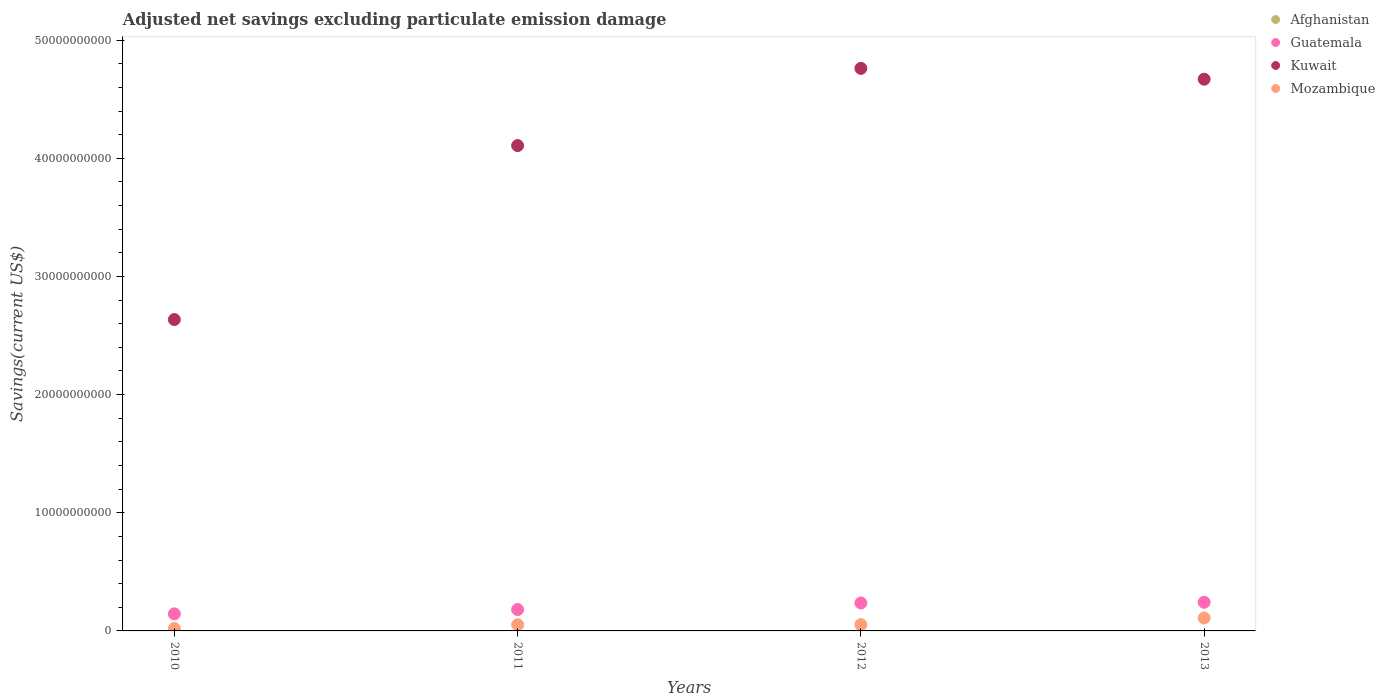What is the adjusted net savings in Mozambique in 2013?
Give a very brief answer. 1.09e+09. Across all years, what is the maximum adjusted net savings in Mozambique?
Your answer should be compact. 1.09e+09. Across all years, what is the minimum adjusted net savings in Mozambique?
Ensure brevity in your answer.  2.04e+08. What is the total adjusted net savings in Afghanistan in the graph?
Give a very brief answer. 0. What is the difference between the adjusted net savings in Guatemala in 2012 and that in 2013?
Make the answer very short. -5.85e+07. What is the difference between the adjusted net savings in Guatemala in 2012 and the adjusted net savings in Mozambique in 2010?
Your answer should be very brief. 2.16e+09. What is the average adjusted net savings in Mozambique per year?
Your answer should be very brief. 5.89e+08. In the year 2011, what is the difference between the adjusted net savings in Mozambique and adjusted net savings in Guatemala?
Provide a short and direct response. -1.28e+09. In how many years, is the adjusted net savings in Kuwait greater than 44000000000 US$?
Provide a short and direct response. 2. What is the ratio of the adjusted net savings in Kuwait in 2010 to that in 2012?
Provide a short and direct response. 0.55. Is the adjusted net savings in Mozambique in 2010 less than that in 2013?
Provide a short and direct response. Yes. Is the difference between the adjusted net savings in Mozambique in 2011 and 2013 greater than the difference between the adjusted net savings in Guatemala in 2011 and 2013?
Make the answer very short. Yes. What is the difference between the highest and the second highest adjusted net savings in Guatemala?
Ensure brevity in your answer.  5.85e+07. What is the difference between the highest and the lowest adjusted net savings in Kuwait?
Keep it short and to the point. 2.13e+1. In how many years, is the adjusted net savings in Mozambique greater than the average adjusted net savings in Mozambique taken over all years?
Keep it short and to the point. 1. Is the sum of the adjusted net savings in Kuwait in 2010 and 2011 greater than the maximum adjusted net savings in Guatemala across all years?
Give a very brief answer. Yes. Is it the case that in every year, the sum of the adjusted net savings in Kuwait and adjusted net savings in Afghanistan  is greater than the adjusted net savings in Guatemala?
Keep it short and to the point. Yes. Does the adjusted net savings in Kuwait monotonically increase over the years?
Keep it short and to the point. No. How many dotlines are there?
Give a very brief answer. 3. What is the difference between two consecutive major ticks on the Y-axis?
Provide a short and direct response. 1.00e+1. Does the graph contain grids?
Your answer should be very brief. No. How many legend labels are there?
Your answer should be very brief. 4. How are the legend labels stacked?
Keep it short and to the point. Vertical. What is the title of the graph?
Give a very brief answer. Adjusted net savings excluding particulate emission damage. Does "Kosovo" appear as one of the legend labels in the graph?
Offer a very short reply. No. What is the label or title of the X-axis?
Your answer should be very brief. Years. What is the label or title of the Y-axis?
Provide a short and direct response. Savings(current US$). What is the Savings(current US$) of Guatemala in 2010?
Offer a very short reply. 1.44e+09. What is the Savings(current US$) in Kuwait in 2010?
Provide a short and direct response. 2.64e+1. What is the Savings(current US$) in Mozambique in 2010?
Keep it short and to the point. 2.04e+08. What is the Savings(current US$) in Afghanistan in 2011?
Your answer should be compact. 0. What is the Savings(current US$) in Guatemala in 2011?
Provide a short and direct response. 1.81e+09. What is the Savings(current US$) of Kuwait in 2011?
Give a very brief answer. 4.11e+1. What is the Savings(current US$) in Mozambique in 2011?
Your answer should be very brief. 5.23e+08. What is the Savings(current US$) of Afghanistan in 2012?
Keep it short and to the point. 0. What is the Savings(current US$) in Guatemala in 2012?
Ensure brevity in your answer.  2.36e+09. What is the Savings(current US$) of Kuwait in 2012?
Your answer should be very brief. 4.76e+1. What is the Savings(current US$) in Mozambique in 2012?
Provide a short and direct response. 5.34e+08. What is the Savings(current US$) of Guatemala in 2013?
Offer a terse response. 2.42e+09. What is the Savings(current US$) in Kuwait in 2013?
Make the answer very short. 4.67e+1. What is the Savings(current US$) of Mozambique in 2013?
Provide a succinct answer. 1.09e+09. Across all years, what is the maximum Savings(current US$) of Guatemala?
Your response must be concise. 2.42e+09. Across all years, what is the maximum Savings(current US$) in Kuwait?
Ensure brevity in your answer.  4.76e+1. Across all years, what is the maximum Savings(current US$) in Mozambique?
Offer a terse response. 1.09e+09. Across all years, what is the minimum Savings(current US$) of Guatemala?
Offer a very short reply. 1.44e+09. Across all years, what is the minimum Savings(current US$) in Kuwait?
Make the answer very short. 2.64e+1. Across all years, what is the minimum Savings(current US$) of Mozambique?
Give a very brief answer. 2.04e+08. What is the total Savings(current US$) in Afghanistan in the graph?
Your answer should be very brief. 0. What is the total Savings(current US$) in Guatemala in the graph?
Your answer should be compact. 8.04e+09. What is the total Savings(current US$) of Kuwait in the graph?
Make the answer very short. 1.62e+11. What is the total Savings(current US$) in Mozambique in the graph?
Offer a terse response. 2.36e+09. What is the difference between the Savings(current US$) of Guatemala in 2010 and that in 2011?
Ensure brevity in your answer.  -3.63e+08. What is the difference between the Savings(current US$) of Kuwait in 2010 and that in 2011?
Offer a terse response. -1.47e+1. What is the difference between the Savings(current US$) in Mozambique in 2010 and that in 2011?
Offer a terse response. -3.19e+08. What is the difference between the Savings(current US$) in Guatemala in 2010 and that in 2012?
Keep it short and to the point. -9.21e+08. What is the difference between the Savings(current US$) of Kuwait in 2010 and that in 2012?
Offer a terse response. -2.13e+1. What is the difference between the Savings(current US$) in Mozambique in 2010 and that in 2012?
Your response must be concise. -3.30e+08. What is the difference between the Savings(current US$) of Guatemala in 2010 and that in 2013?
Provide a short and direct response. -9.80e+08. What is the difference between the Savings(current US$) of Kuwait in 2010 and that in 2013?
Give a very brief answer. -2.03e+1. What is the difference between the Savings(current US$) in Mozambique in 2010 and that in 2013?
Your response must be concise. -8.91e+08. What is the difference between the Savings(current US$) of Guatemala in 2011 and that in 2012?
Your response must be concise. -5.58e+08. What is the difference between the Savings(current US$) in Kuwait in 2011 and that in 2012?
Provide a short and direct response. -6.53e+09. What is the difference between the Savings(current US$) in Mozambique in 2011 and that in 2012?
Offer a terse response. -1.03e+07. What is the difference between the Savings(current US$) in Guatemala in 2011 and that in 2013?
Offer a very short reply. -6.17e+08. What is the difference between the Savings(current US$) in Kuwait in 2011 and that in 2013?
Provide a succinct answer. -5.62e+09. What is the difference between the Savings(current US$) of Mozambique in 2011 and that in 2013?
Offer a terse response. -5.71e+08. What is the difference between the Savings(current US$) in Guatemala in 2012 and that in 2013?
Provide a succinct answer. -5.85e+07. What is the difference between the Savings(current US$) of Kuwait in 2012 and that in 2013?
Ensure brevity in your answer.  9.16e+08. What is the difference between the Savings(current US$) in Mozambique in 2012 and that in 2013?
Offer a very short reply. -5.61e+08. What is the difference between the Savings(current US$) in Guatemala in 2010 and the Savings(current US$) in Kuwait in 2011?
Your response must be concise. -3.96e+1. What is the difference between the Savings(current US$) in Guatemala in 2010 and the Savings(current US$) in Mozambique in 2011?
Your answer should be very brief. 9.20e+08. What is the difference between the Savings(current US$) of Kuwait in 2010 and the Savings(current US$) of Mozambique in 2011?
Provide a short and direct response. 2.58e+1. What is the difference between the Savings(current US$) of Guatemala in 2010 and the Savings(current US$) of Kuwait in 2012?
Ensure brevity in your answer.  -4.62e+1. What is the difference between the Savings(current US$) of Guatemala in 2010 and the Savings(current US$) of Mozambique in 2012?
Your answer should be very brief. 9.10e+08. What is the difference between the Savings(current US$) in Kuwait in 2010 and the Savings(current US$) in Mozambique in 2012?
Offer a terse response. 2.58e+1. What is the difference between the Savings(current US$) of Guatemala in 2010 and the Savings(current US$) of Kuwait in 2013?
Your answer should be compact. -4.52e+1. What is the difference between the Savings(current US$) in Guatemala in 2010 and the Savings(current US$) in Mozambique in 2013?
Provide a succinct answer. 3.49e+08. What is the difference between the Savings(current US$) of Kuwait in 2010 and the Savings(current US$) of Mozambique in 2013?
Provide a short and direct response. 2.53e+1. What is the difference between the Savings(current US$) of Guatemala in 2011 and the Savings(current US$) of Kuwait in 2012?
Provide a short and direct response. -4.58e+1. What is the difference between the Savings(current US$) in Guatemala in 2011 and the Savings(current US$) in Mozambique in 2012?
Keep it short and to the point. 1.27e+09. What is the difference between the Savings(current US$) of Kuwait in 2011 and the Savings(current US$) of Mozambique in 2012?
Keep it short and to the point. 4.05e+1. What is the difference between the Savings(current US$) of Guatemala in 2011 and the Savings(current US$) of Kuwait in 2013?
Ensure brevity in your answer.  -4.49e+1. What is the difference between the Savings(current US$) of Guatemala in 2011 and the Savings(current US$) of Mozambique in 2013?
Give a very brief answer. 7.12e+08. What is the difference between the Savings(current US$) in Kuwait in 2011 and the Savings(current US$) in Mozambique in 2013?
Make the answer very short. 4.00e+1. What is the difference between the Savings(current US$) of Guatemala in 2012 and the Savings(current US$) of Kuwait in 2013?
Give a very brief answer. -4.43e+1. What is the difference between the Savings(current US$) of Guatemala in 2012 and the Savings(current US$) of Mozambique in 2013?
Your answer should be compact. 1.27e+09. What is the difference between the Savings(current US$) in Kuwait in 2012 and the Savings(current US$) in Mozambique in 2013?
Provide a succinct answer. 4.65e+1. What is the average Savings(current US$) of Afghanistan per year?
Your answer should be compact. 0. What is the average Savings(current US$) in Guatemala per year?
Provide a short and direct response. 2.01e+09. What is the average Savings(current US$) of Kuwait per year?
Give a very brief answer. 4.04e+1. What is the average Savings(current US$) in Mozambique per year?
Offer a terse response. 5.89e+08. In the year 2010, what is the difference between the Savings(current US$) in Guatemala and Savings(current US$) in Kuwait?
Keep it short and to the point. -2.49e+1. In the year 2010, what is the difference between the Savings(current US$) in Guatemala and Savings(current US$) in Mozambique?
Your answer should be compact. 1.24e+09. In the year 2010, what is the difference between the Savings(current US$) of Kuwait and Savings(current US$) of Mozambique?
Your answer should be compact. 2.61e+1. In the year 2011, what is the difference between the Savings(current US$) in Guatemala and Savings(current US$) in Kuwait?
Keep it short and to the point. -3.93e+1. In the year 2011, what is the difference between the Savings(current US$) of Guatemala and Savings(current US$) of Mozambique?
Offer a very short reply. 1.28e+09. In the year 2011, what is the difference between the Savings(current US$) of Kuwait and Savings(current US$) of Mozambique?
Your answer should be very brief. 4.05e+1. In the year 2012, what is the difference between the Savings(current US$) of Guatemala and Savings(current US$) of Kuwait?
Keep it short and to the point. -4.52e+1. In the year 2012, what is the difference between the Savings(current US$) in Guatemala and Savings(current US$) in Mozambique?
Keep it short and to the point. 1.83e+09. In the year 2012, what is the difference between the Savings(current US$) in Kuwait and Savings(current US$) in Mozambique?
Make the answer very short. 4.71e+1. In the year 2013, what is the difference between the Savings(current US$) in Guatemala and Savings(current US$) in Kuwait?
Give a very brief answer. -4.43e+1. In the year 2013, what is the difference between the Savings(current US$) in Guatemala and Savings(current US$) in Mozambique?
Provide a succinct answer. 1.33e+09. In the year 2013, what is the difference between the Savings(current US$) of Kuwait and Savings(current US$) of Mozambique?
Provide a short and direct response. 4.56e+1. What is the ratio of the Savings(current US$) in Guatemala in 2010 to that in 2011?
Your response must be concise. 0.8. What is the ratio of the Savings(current US$) of Kuwait in 2010 to that in 2011?
Your answer should be very brief. 0.64. What is the ratio of the Savings(current US$) in Mozambique in 2010 to that in 2011?
Keep it short and to the point. 0.39. What is the ratio of the Savings(current US$) in Guatemala in 2010 to that in 2012?
Offer a very short reply. 0.61. What is the ratio of the Savings(current US$) of Kuwait in 2010 to that in 2012?
Your response must be concise. 0.55. What is the ratio of the Savings(current US$) in Mozambique in 2010 to that in 2012?
Keep it short and to the point. 0.38. What is the ratio of the Savings(current US$) in Guatemala in 2010 to that in 2013?
Ensure brevity in your answer.  0.6. What is the ratio of the Savings(current US$) in Kuwait in 2010 to that in 2013?
Offer a very short reply. 0.56. What is the ratio of the Savings(current US$) of Mozambique in 2010 to that in 2013?
Provide a short and direct response. 0.19. What is the ratio of the Savings(current US$) of Guatemala in 2011 to that in 2012?
Your answer should be compact. 0.76. What is the ratio of the Savings(current US$) of Kuwait in 2011 to that in 2012?
Make the answer very short. 0.86. What is the ratio of the Savings(current US$) of Mozambique in 2011 to that in 2012?
Your answer should be compact. 0.98. What is the ratio of the Savings(current US$) of Guatemala in 2011 to that in 2013?
Ensure brevity in your answer.  0.75. What is the ratio of the Savings(current US$) in Kuwait in 2011 to that in 2013?
Offer a very short reply. 0.88. What is the ratio of the Savings(current US$) in Mozambique in 2011 to that in 2013?
Your answer should be compact. 0.48. What is the ratio of the Savings(current US$) of Guatemala in 2012 to that in 2013?
Offer a very short reply. 0.98. What is the ratio of the Savings(current US$) in Kuwait in 2012 to that in 2013?
Keep it short and to the point. 1.02. What is the ratio of the Savings(current US$) in Mozambique in 2012 to that in 2013?
Provide a short and direct response. 0.49. What is the difference between the highest and the second highest Savings(current US$) in Guatemala?
Your answer should be compact. 5.85e+07. What is the difference between the highest and the second highest Savings(current US$) in Kuwait?
Make the answer very short. 9.16e+08. What is the difference between the highest and the second highest Savings(current US$) of Mozambique?
Ensure brevity in your answer.  5.61e+08. What is the difference between the highest and the lowest Savings(current US$) in Guatemala?
Give a very brief answer. 9.80e+08. What is the difference between the highest and the lowest Savings(current US$) in Kuwait?
Offer a terse response. 2.13e+1. What is the difference between the highest and the lowest Savings(current US$) of Mozambique?
Your answer should be compact. 8.91e+08. 